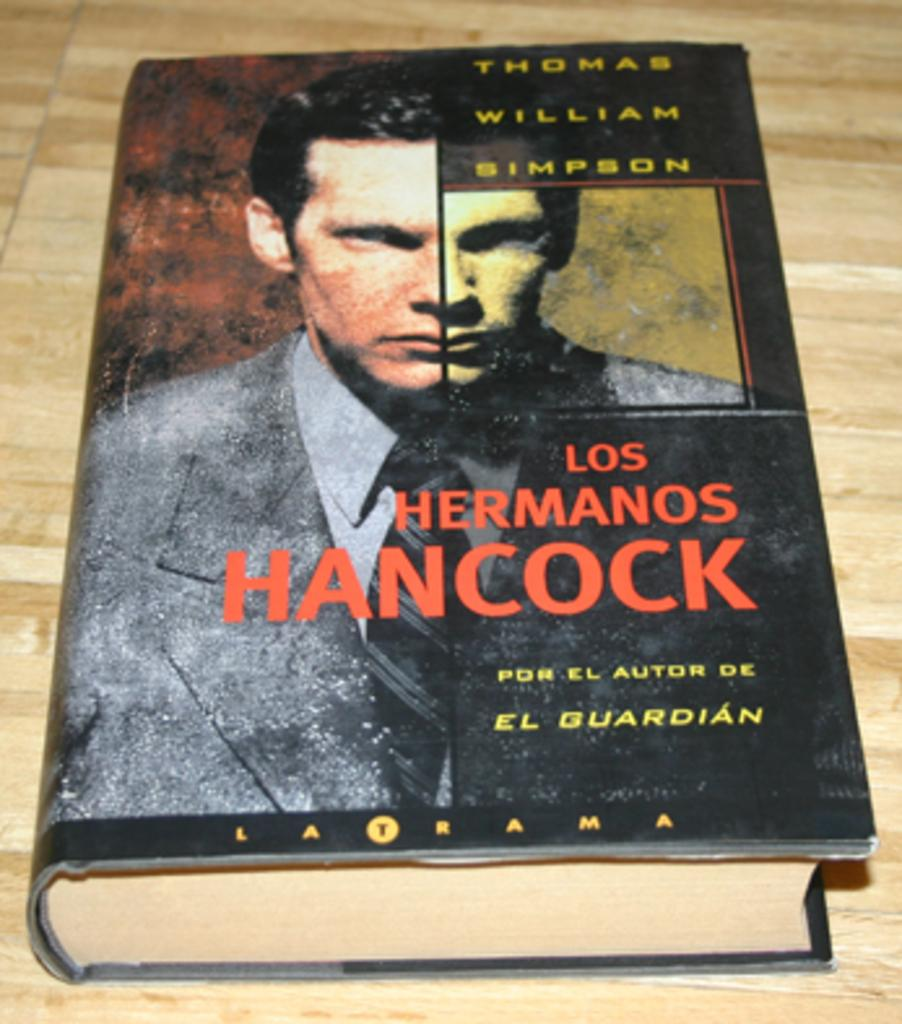<image>
Render a clear and concise summary of the photo. a thomas william simpson book is laying on a table 